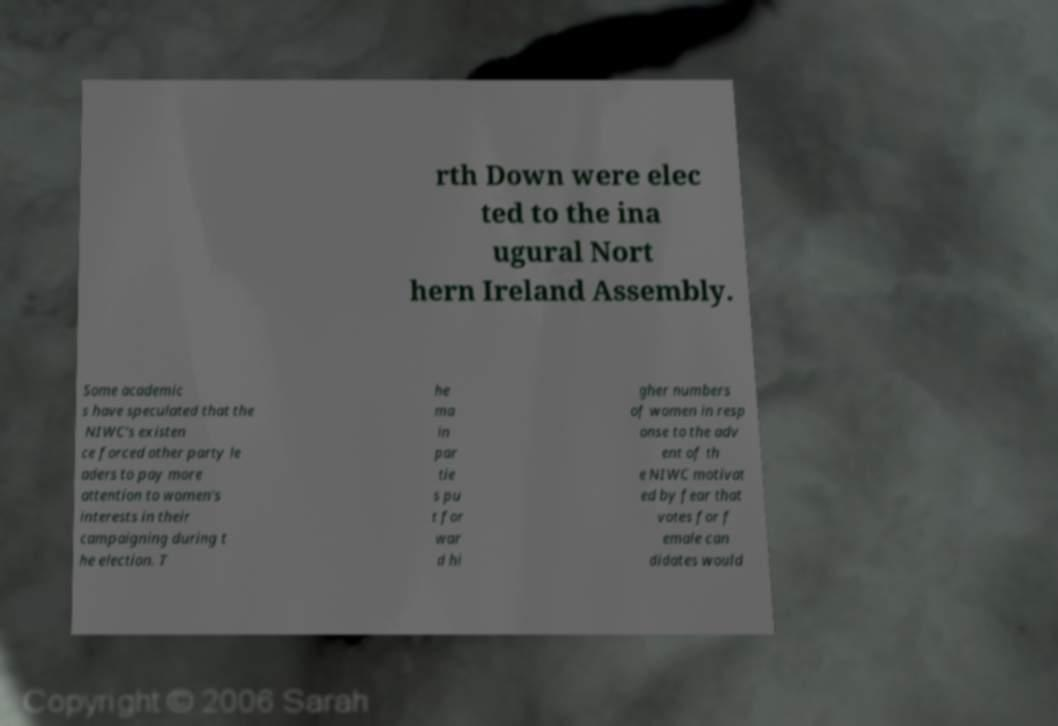There's text embedded in this image that I need extracted. Can you transcribe it verbatim? rth Down were elec ted to the ina ugural Nort hern Ireland Assembly. Some academic s have speculated that the NIWC's existen ce forced other party le aders to pay more attention to women's interests in their campaigning during t he election. T he ma in par tie s pu t for war d hi gher numbers of women in resp onse to the adv ent of th e NIWC motivat ed by fear that votes for f emale can didates would 